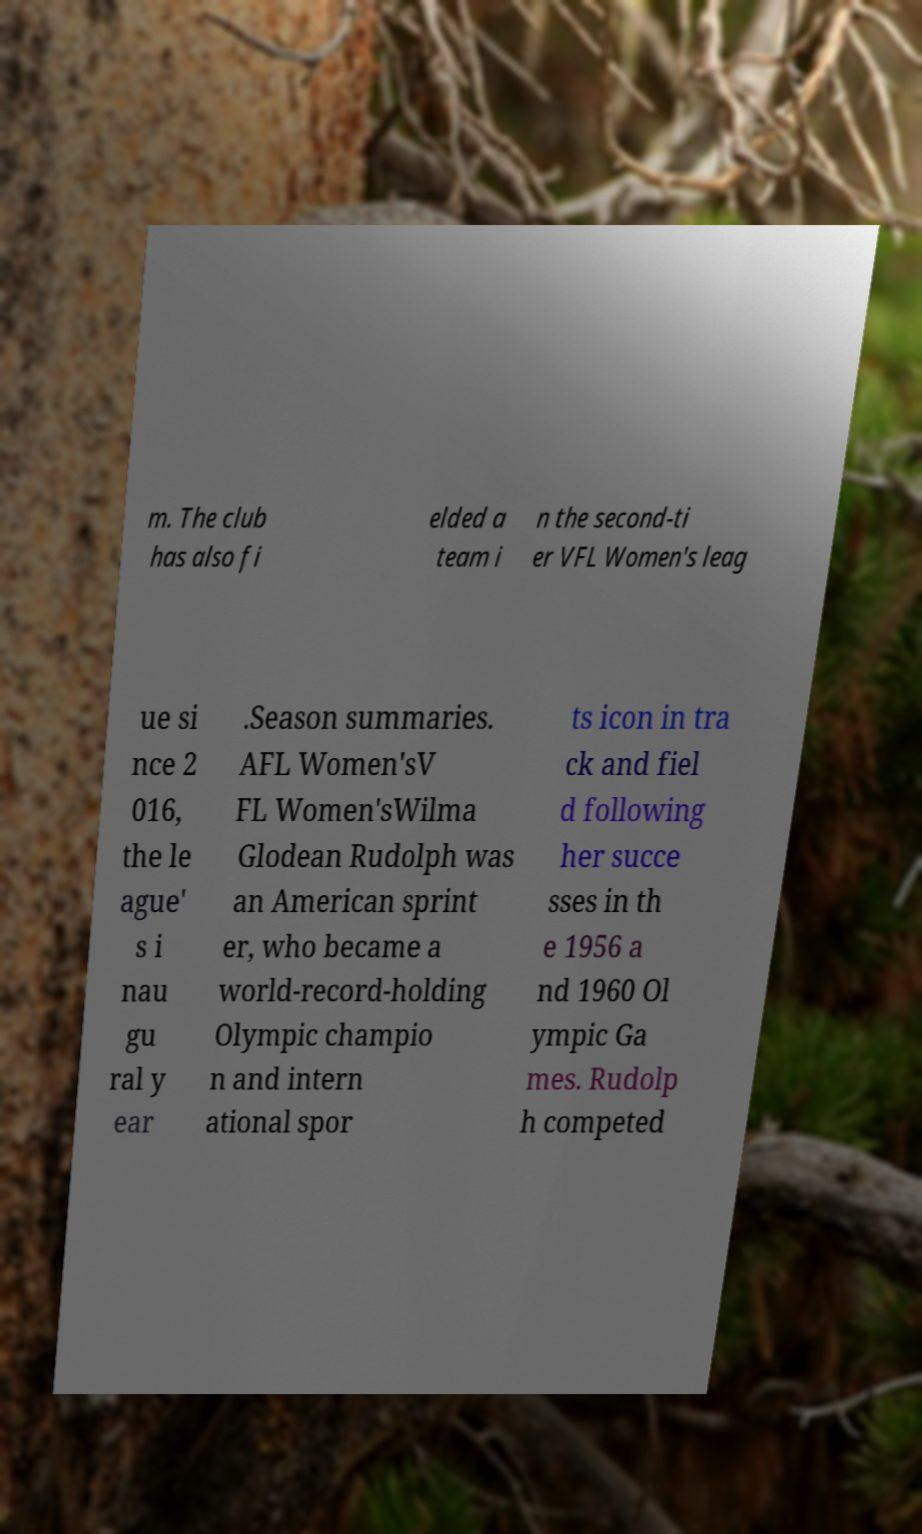Could you extract and type out the text from this image? m. The club has also fi elded a team i n the second-ti er VFL Women's leag ue si nce 2 016, the le ague' s i nau gu ral y ear .Season summaries. AFL Women'sV FL Women'sWilma Glodean Rudolph was an American sprint er, who became a world-record-holding Olympic champio n and intern ational spor ts icon in tra ck and fiel d following her succe sses in th e 1956 a nd 1960 Ol ympic Ga mes. Rudolp h competed 